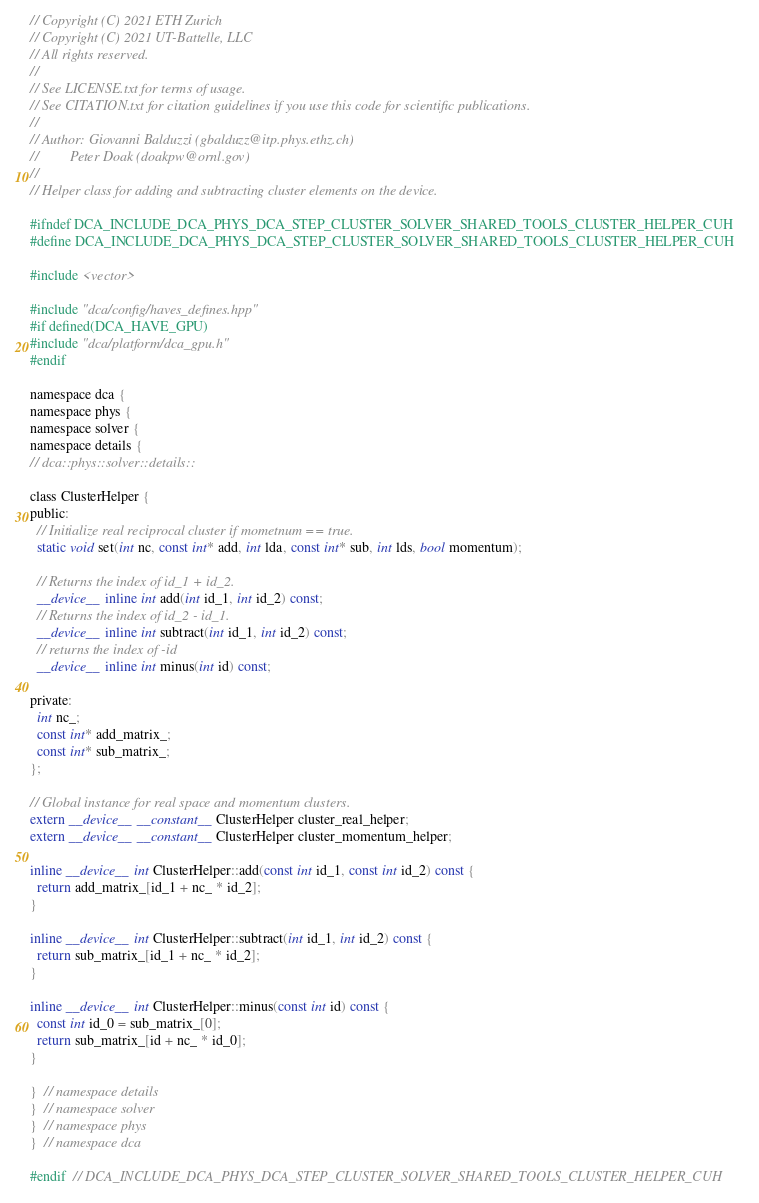Convert code to text. <code><loc_0><loc_0><loc_500><loc_500><_Cuda_>// Copyright (C) 2021 ETH Zurich
// Copyright (C) 2021 UT-Battelle, LLC
// All rights reserved.
//
// See LICENSE.txt for terms of usage.
// See CITATION.txt for citation guidelines if you use this code for scientific publications.
//
// Author: Giovanni Balduzzi (gbalduzz@itp.phys.ethz.ch)
//         Peter Doak (doakpw@ornl.gov)
//
// Helper class for adding and subtracting cluster elements on the device.

#ifndef DCA_INCLUDE_DCA_PHYS_DCA_STEP_CLUSTER_SOLVER_SHARED_TOOLS_CLUSTER_HELPER_CUH
#define DCA_INCLUDE_DCA_PHYS_DCA_STEP_CLUSTER_SOLVER_SHARED_TOOLS_CLUSTER_HELPER_CUH

#include <vector>

#include "dca/config/haves_defines.hpp"
#if defined(DCA_HAVE_GPU)
#include "dca/platform/dca_gpu.h"
#endif

namespace dca {
namespace phys {
namespace solver {
namespace details {
// dca::phys::solver::details::

class ClusterHelper {
public:
  // Initialize real reciprocal cluster if mometnum == true.
  static void set(int nc, const int* add, int lda, const int* sub, int lds, bool momentum);

  // Returns the index of id_1 + id_2.
  __device__ inline int add(int id_1, int id_2) const;
  // Returns the index of id_2 - id_1.
  __device__ inline int subtract(int id_1, int id_2) const;
  // returns the index of -id
  __device__ inline int minus(int id) const;

private:
  int nc_;
  const int* add_matrix_;
  const int* sub_matrix_;
};

// Global instance for real space and momentum clusters.
extern __device__ __constant__ ClusterHelper cluster_real_helper;
extern __device__ __constant__ ClusterHelper cluster_momentum_helper;

inline __device__ int ClusterHelper::add(const int id_1, const int id_2) const {
  return add_matrix_[id_1 + nc_ * id_2];
}

inline __device__ int ClusterHelper::subtract(int id_1, int id_2) const {
  return sub_matrix_[id_1 + nc_ * id_2];
}

inline __device__ int ClusterHelper::minus(const int id) const {
  const int id_0 = sub_matrix_[0];
  return sub_matrix_[id + nc_ * id_0];
}

}  // namespace details
}  // namespace solver
}  // namespace phys
}  // namespace dca

#endif  // DCA_INCLUDE_DCA_PHYS_DCA_STEP_CLUSTER_SOLVER_SHARED_TOOLS_CLUSTER_HELPER_CUH
</code> 